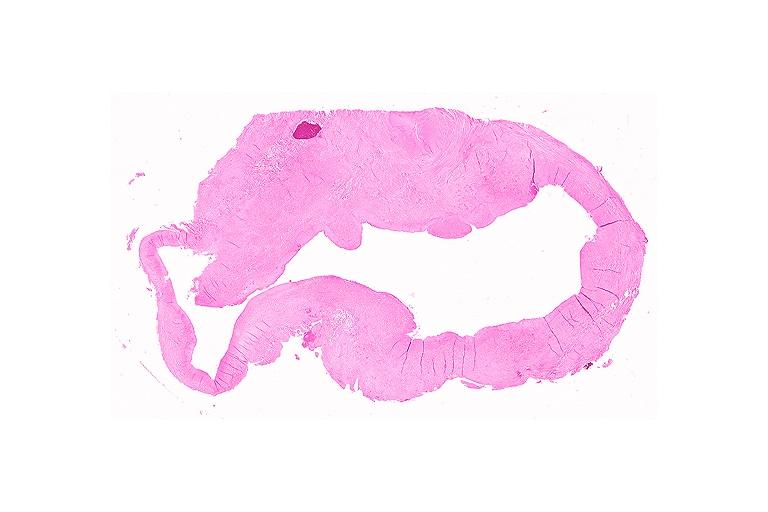s thymoma present?
Answer the question using a single word or phrase. No 